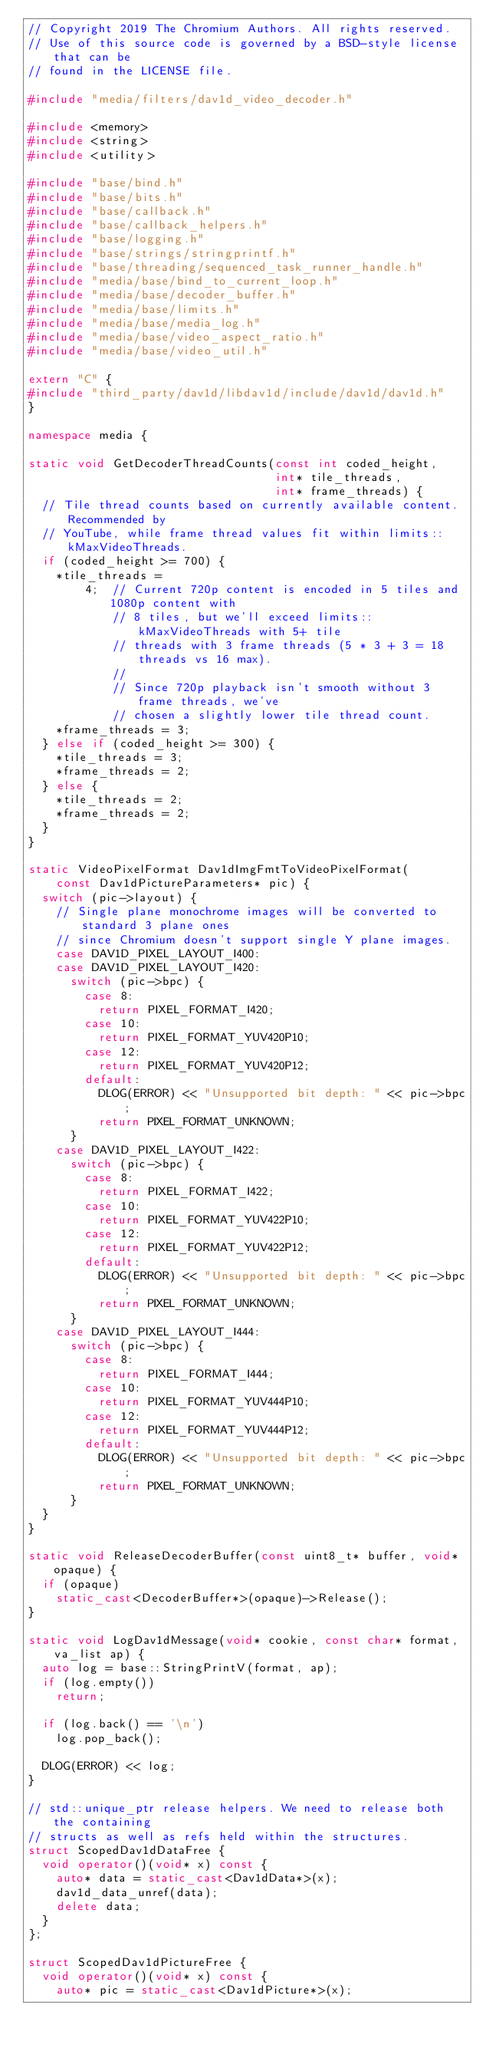<code> <loc_0><loc_0><loc_500><loc_500><_C++_>// Copyright 2019 The Chromium Authors. All rights reserved.
// Use of this source code is governed by a BSD-style license that can be
// found in the LICENSE file.

#include "media/filters/dav1d_video_decoder.h"

#include <memory>
#include <string>
#include <utility>

#include "base/bind.h"
#include "base/bits.h"
#include "base/callback.h"
#include "base/callback_helpers.h"
#include "base/logging.h"
#include "base/strings/stringprintf.h"
#include "base/threading/sequenced_task_runner_handle.h"
#include "media/base/bind_to_current_loop.h"
#include "media/base/decoder_buffer.h"
#include "media/base/limits.h"
#include "media/base/media_log.h"
#include "media/base/video_aspect_ratio.h"
#include "media/base/video_util.h"

extern "C" {
#include "third_party/dav1d/libdav1d/include/dav1d/dav1d.h"
}

namespace media {

static void GetDecoderThreadCounts(const int coded_height,
                                   int* tile_threads,
                                   int* frame_threads) {
  // Tile thread counts based on currently available content. Recommended by
  // YouTube, while frame thread values fit within limits::kMaxVideoThreads.
  if (coded_height >= 700) {
    *tile_threads =
        4;  // Current 720p content is encoded in 5 tiles and 1080p content with
            // 8 tiles, but we'll exceed limits::kMaxVideoThreads with 5+ tile
            // threads with 3 frame threads (5 * 3 + 3 = 18 threads vs 16 max).
            //
            // Since 720p playback isn't smooth without 3 frame threads, we've
            // chosen a slightly lower tile thread count.
    *frame_threads = 3;
  } else if (coded_height >= 300) {
    *tile_threads = 3;
    *frame_threads = 2;
  } else {
    *tile_threads = 2;
    *frame_threads = 2;
  }
}

static VideoPixelFormat Dav1dImgFmtToVideoPixelFormat(
    const Dav1dPictureParameters* pic) {
  switch (pic->layout) {
    // Single plane monochrome images will be converted to standard 3 plane ones
    // since Chromium doesn't support single Y plane images.
    case DAV1D_PIXEL_LAYOUT_I400:
    case DAV1D_PIXEL_LAYOUT_I420:
      switch (pic->bpc) {
        case 8:
          return PIXEL_FORMAT_I420;
        case 10:
          return PIXEL_FORMAT_YUV420P10;
        case 12:
          return PIXEL_FORMAT_YUV420P12;
        default:
          DLOG(ERROR) << "Unsupported bit depth: " << pic->bpc;
          return PIXEL_FORMAT_UNKNOWN;
      }
    case DAV1D_PIXEL_LAYOUT_I422:
      switch (pic->bpc) {
        case 8:
          return PIXEL_FORMAT_I422;
        case 10:
          return PIXEL_FORMAT_YUV422P10;
        case 12:
          return PIXEL_FORMAT_YUV422P12;
        default:
          DLOG(ERROR) << "Unsupported bit depth: " << pic->bpc;
          return PIXEL_FORMAT_UNKNOWN;
      }
    case DAV1D_PIXEL_LAYOUT_I444:
      switch (pic->bpc) {
        case 8:
          return PIXEL_FORMAT_I444;
        case 10:
          return PIXEL_FORMAT_YUV444P10;
        case 12:
          return PIXEL_FORMAT_YUV444P12;
        default:
          DLOG(ERROR) << "Unsupported bit depth: " << pic->bpc;
          return PIXEL_FORMAT_UNKNOWN;
      }
  }
}

static void ReleaseDecoderBuffer(const uint8_t* buffer, void* opaque) {
  if (opaque)
    static_cast<DecoderBuffer*>(opaque)->Release();
}

static void LogDav1dMessage(void* cookie, const char* format, va_list ap) {
  auto log = base::StringPrintV(format, ap);
  if (log.empty())
    return;

  if (log.back() == '\n')
    log.pop_back();

  DLOG(ERROR) << log;
}

// std::unique_ptr release helpers. We need to release both the containing
// structs as well as refs held within the structures.
struct ScopedDav1dDataFree {
  void operator()(void* x) const {
    auto* data = static_cast<Dav1dData*>(x);
    dav1d_data_unref(data);
    delete data;
  }
};

struct ScopedDav1dPictureFree {
  void operator()(void* x) const {
    auto* pic = static_cast<Dav1dPicture*>(x);</code> 